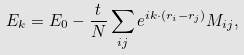<formula> <loc_0><loc_0><loc_500><loc_500>E _ { k } = E _ { 0 } - \frac { t } { N } \sum _ { i j } e ^ { i { k } \cdot ( { r } _ { i } - { r } _ { j } ) } M _ { i j } ,</formula> 